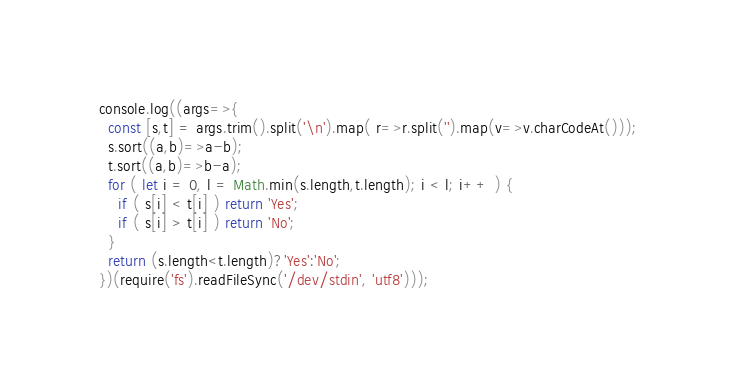Convert code to text. <code><loc_0><loc_0><loc_500><loc_500><_JavaScript_>console.log((args=>{
  const [s,t] = args.trim().split('\n').map( r=>r.split('').map(v=>v.charCodeAt()));
  s.sort((a,b)=>a-b);
  t.sort((a,b)=>b-a);
  for ( let i = 0, l = Math.min(s.length,t.length); i < l; i++ ) {
    if ( s[i] < t[i] ) return 'Yes';
    if ( s[i] > t[i] ) return 'No';
  }
  return (s.length<t.length)?'Yes':'No';
})(require('fs').readFileSync('/dev/stdin', 'utf8')));
</code> 